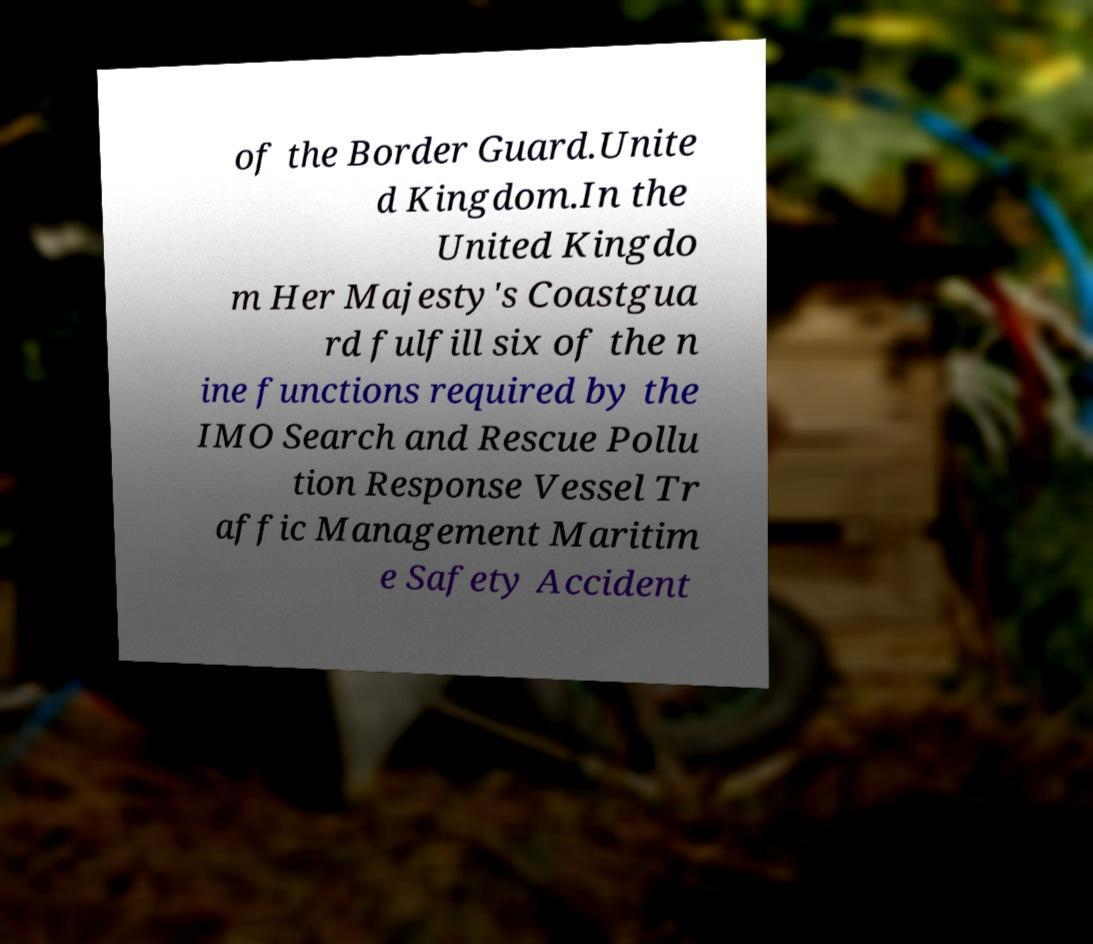There's text embedded in this image that I need extracted. Can you transcribe it verbatim? of the Border Guard.Unite d Kingdom.In the United Kingdo m Her Majesty's Coastgua rd fulfill six of the n ine functions required by the IMO Search and Rescue Pollu tion Response Vessel Tr affic Management Maritim e Safety Accident 